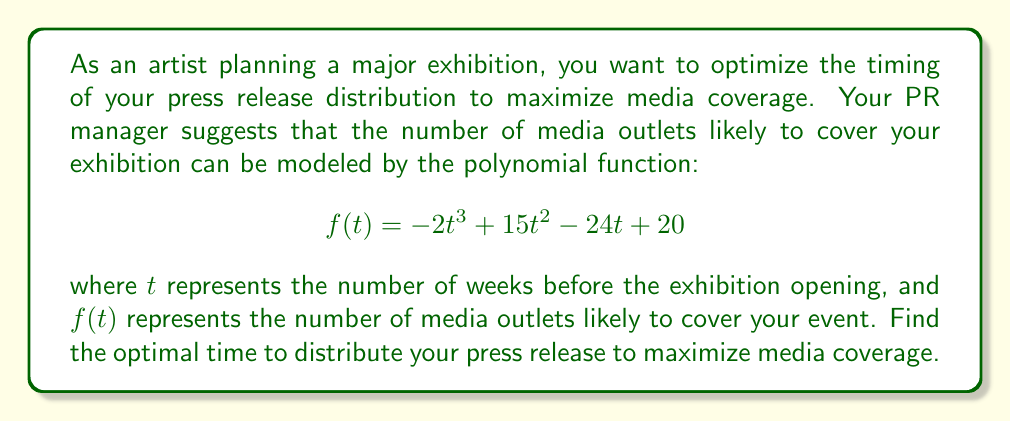Show me your answer to this math problem. To find the optimal time for press release distribution, we need to find the maximum value of the function $f(t)$. This occurs where the derivative of the function equals zero.

1. First, let's find the derivative of $f(t)$:
   $$f'(t) = -6t^2 + 30t - 24$$

2. Set the derivative equal to zero and solve for t:
   $$-6t^2 + 30t - 24 = 0$$

3. This is a quadratic equation. We can solve it using the quadratic formula:
   $$t = \frac{-b \pm \sqrt{b^2 - 4ac}}{2a}$$
   where $a = -6$, $b = 30$, and $c = -24$

4. Substituting these values:
   $$t = \frac{-30 \pm \sqrt{30^2 - 4(-6)(-24)}}{2(-6)}$$
   $$t = \frac{-30 \pm \sqrt{900 - 576}}{-12}$$
   $$t = \frac{-30 \pm \sqrt{324}}{-12}$$
   $$t = \frac{-30 \pm 18}{-12}$$

5. This gives us two solutions:
   $$t = \frac{-30 + 18}{-12} = 1 \quad \text{or} \quad t = \frac{-30 - 18}{-12} = 4$$

6. To determine which of these is the maximum (rather than the minimum), we can check the second derivative:
   $$f''(t) = -12t + 30$$

   At $t = 1$: $f''(1) = -12(1) + 30 = 18 > 0$, indicating a local minimum
   At $t = 4$: $f''(4) = -12(4) + 30 = -18 < 0$, indicating a local maximum

Therefore, the maximum occurs at $t = 4$ weeks before the exhibition opening.
Answer: The optimal time to distribute the press release is 4 weeks before the exhibition opening. 